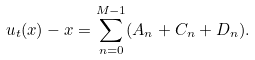Convert formula to latex. <formula><loc_0><loc_0><loc_500><loc_500>u _ { t } ( x ) - x = \sum _ { n = 0 } ^ { M - 1 } ( A _ { n } + C _ { n } + D _ { n } ) .</formula> 